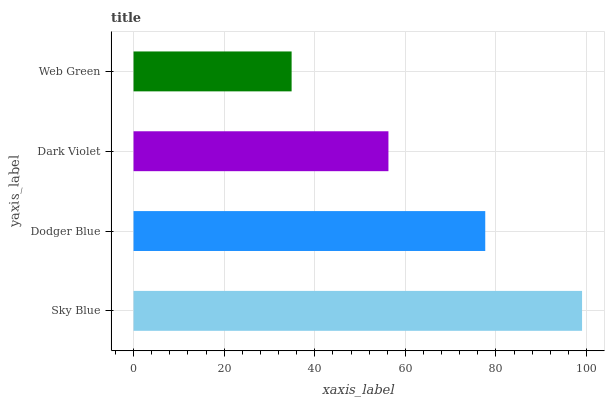Is Web Green the minimum?
Answer yes or no. Yes. Is Sky Blue the maximum?
Answer yes or no. Yes. Is Dodger Blue the minimum?
Answer yes or no. No. Is Dodger Blue the maximum?
Answer yes or no. No. Is Sky Blue greater than Dodger Blue?
Answer yes or no. Yes. Is Dodger Blue less than Sky Blue?
Answer yes or no. Yes. Is Dodger Blue greater than Sky Blue?
Answer yes or no. No. Is Sky Blue less than Dodger Blue?
Answer yes or no. No. Is Dodger Blue the high median?
Answer yes or no. Yes. Is Dark Violet the low median?
Answer yes or no. Yes. Is Sky Blue the high median?
Answer yes or no. No. Is Sky Blue the low median?
Answer yes or no. No. 